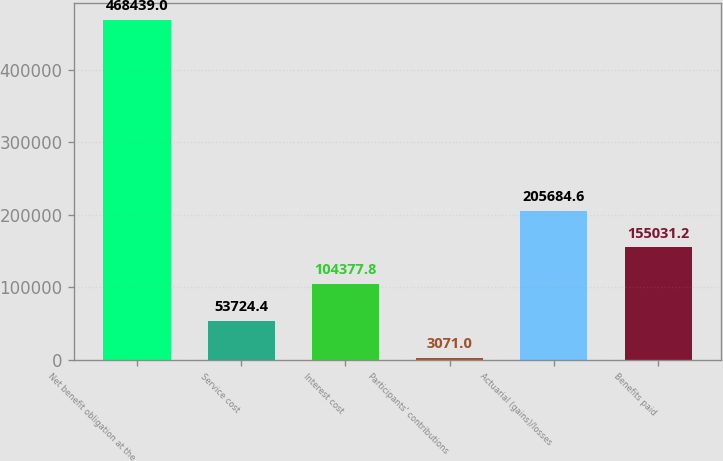Convert chart to OTSL. <chart><loc_0><loc_0><loc_500><loc_500><bar_chart><fcel>Net benefit obligation at the<fcel>Service cost<fcel>Interest cost<fcel>Participants' contributions<fcel>Actuarial (gains)/losses<fcel>Benefits paid<nl><fcel>468439<fcel>53724.4<fcel>104378<fcel>3071<fcel>205685<fcel>155031<nl></chart> 